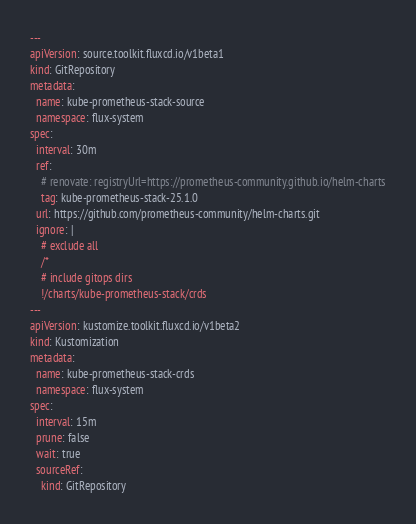Convert code to text. <code><loc_0><loc_0><loc_500><loc_500><_YAML_>---
apiVersion: source.toolkit.fluxcd.io/v1beta1
kind: GitRepository
metadata:
  name: kube-prometheus-stack-source
  namespace: flux-system
spec:
  interval: 30m
  ref:
    # renovate: registryUrl=https://prometheus-community.github.io/helm-charts
    tag: kube-prometheus-stack-25.1.0
  url: https://github.com/prometheus-community/helm-charts.git
  ignore: |
    # exclude all
    /*
    # include gitops dirs
    !/charts/kube-prometheus-stack/crds
---
apiVersion: kustomize.toolkit.fluxcd.io/v1beta2
kind: Kustomization
metadata:
  name: kube-prometheus-stack-crds
  namespace: flux-system
spec:
  interval: 15m
  prune: false
  wait: true
  sourceRef:
    kind: GitRepository</code> 